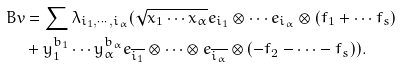<formula> <loc_0><loc_0><loc_500><loc_500>B v & = \sum \lambda _ { i _ { 1 } , \cdots , i _ { \alpha } } ( \sqrt { x _ { 1 } \cdots x _ { \alpha } } e _ { i _ { 1 } } \otimes \cdots e _ { i _ { \alpha } } \otimes ( f _ { 1 } + \cdots f _ { s } ) \\ & + y _ { 1 } ^ { b _ { 1 } } \cdots y _ { \alpha } ^ { b _ { \alpha } } e _ { \overline { i _ { 1 } } } \otimes \cdots \otimes e _ { \overline { i _ { \alpha } } } \otimes ( - f _ { 2 } - \cdots - f _ { s } ) ) .</formula> 